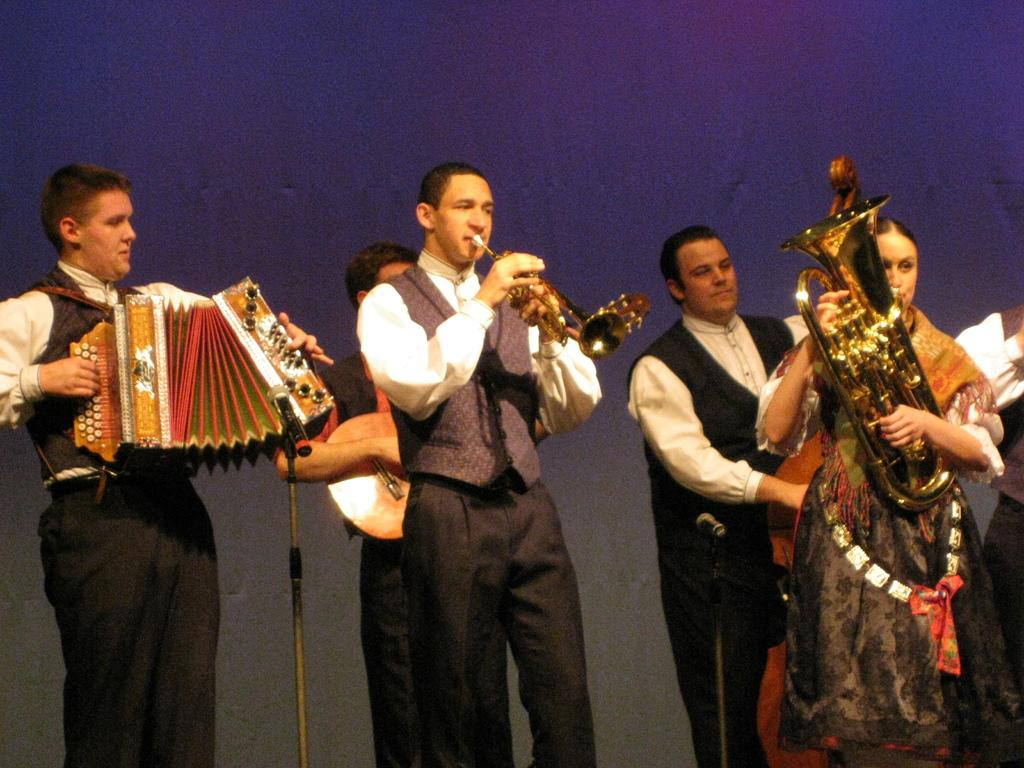What are the people in the image doing? The people in the image are playing musical instruments. Where are the people located in the image? The people are standing in the center of the image. What object is placed at the bottom of the image? There is a mic placed on a stand at the bottom of the image. Can you see a shoe being thrown in the air during the performance in the image? There is no shoe being thrown in the air during the performance in the image. Are the people in the image kissing each other while playing their instruments? There is no indication in the image that the people are kissing each other while playing their instruments. 